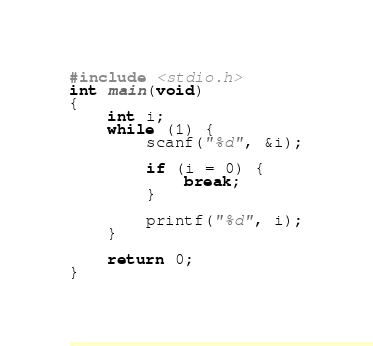<code> <loc_0><loc_0><loc_500><loc_500><_C_>#include <stdio.h>
int main(void)
{
	int i;
	while (1) {
		scanf("%d", &i);

		if (i = 0) {
			break;
		}

		printf("%d", i);
	}

    return 0;
}
</code> 